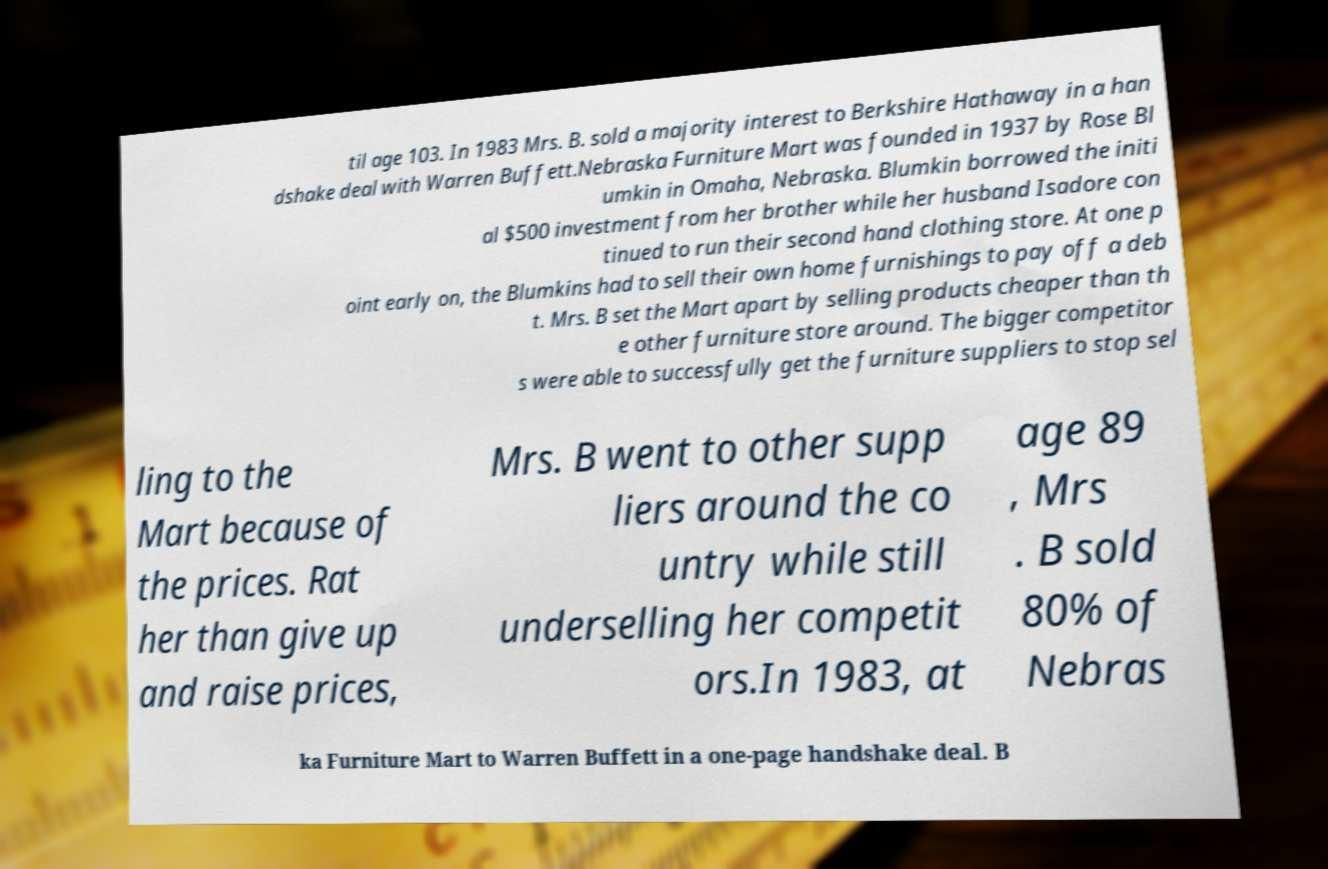For documentation purposes, I need the text within this image transcribed. Could you provide that? til age 103. In 1983 Mrs. B. sold a majority interest to Berkshire Hathaway in a han dshake deal with Warren Buffett.Nebraska Furniture Mart was founded in 1937 by Rose Bl umkin in Omaha, Nebraska. Blumkin borrowed the initi al $500 investment from her brother while her husband Isadore con tinued to run their second hand clothing store. At one p oint early on, the Blumkins had to sell their own home furnishings to pay off a deb t. Mrs. B set the Mart apart by selling products cheaper than th e other furniture store around. The bigger competitor s were able to successfully get the furniture suppliers to stop sel ling to the Mart because of the prices. Rat her than give up and raise prices, Mrs. B went to other supp liers around the co untry while still underselling her competit ors.In 1983, at age 89 , Mrs . B sold 80% of Nebras ka Furniture Mart to Warren Buffett in a one-page handshake deal. B 